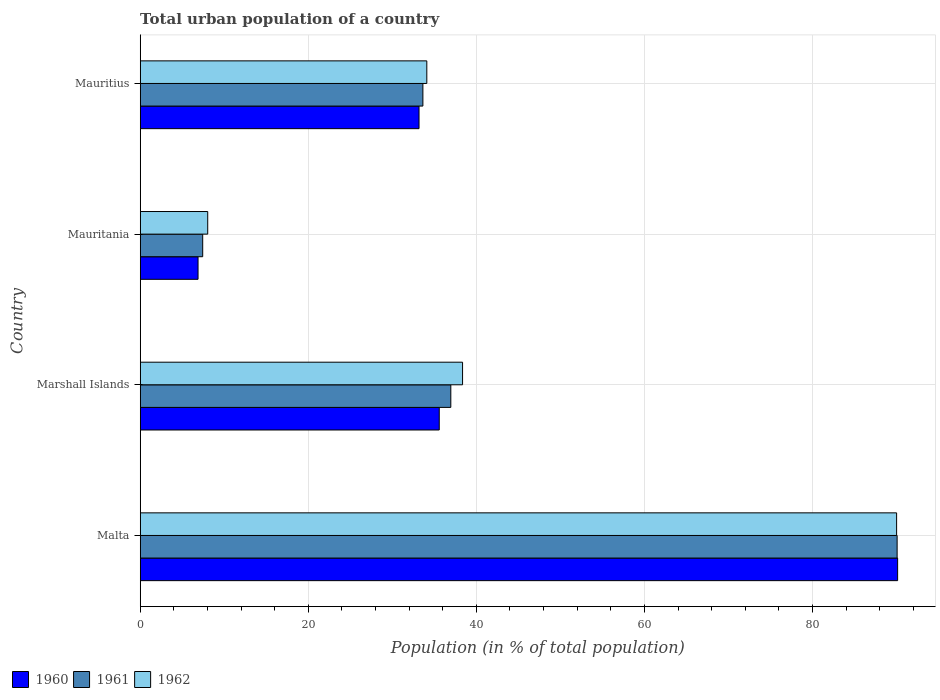How many different coloured bars are there?
Provide a short and direct response. 3. How many groups of bars are there?
Offer a terse response. 4. What is the label of the 1st group of bars from the top?
Provide a short and direct response. Mauritius. What is the urban population in 1961 in Mauritius?
Provide a succinct answer. 33.64. Across all countries, what is the maximum urban population in 1960?
Offer a very short reply. 90.13. Across all countries, what is the minimum urban population in 1960?
Provide a short and direct response. 6.88. In which country was the urban population in 1961 maximum?
Offer a terse response. Malta. In which country was the urban population in 1961 minimum?
Keep it short and to the point. Mauritania. What is the total urban population in 1961 in the graph?
Provide a short and direct response. 168.1. What is the difference between the urban population in 1960 in Marshall Islands and that in Mauritania?
Offer a terse response. 28.7. What is the difference between the urban population in 1962 in Marshall Islands and the urban population in 1960 in Mauritania?
Your response must be concise. 31.48. What is the average urban population in 1960 per country?
Your answer should be very brief. 41.44. What is the difference between the urban population in 1961 and urban population in 1960 in Marshall Islands?
Make the answer very short. 1.38. What is the ratio of the urban population in 1962 in Malta to that in Marshall Islands?
Provide a succinct answer. 2.35. Is the urban population in 1960 in Marshall Islands less than that in Mauritania?
Ensure brevity in your answer.  No. Is the difference between the urban population in 1961 in Marshall Islands and Mauritania greater than the difference between the urban population in 1960 in Marshall Islands and Mauritania?
Offer a very short reply. Yes. What is the difference between the highest and the second highest urban population in 1961?
Your answer should be very brief. 53.11. What is the difference between the highest and the lowest urban population in 1962?
Provide a short and direct response. 81.98. In how many countries, is the urban population in 1960 greater than the average urban population in 1960 taken over all countries?
Keep it short and to the point. 1. What does the 1st bar from the bottom in Malta represents?
Provide a short and direct response. 1960. Are all the bars in the graph horizontal?
Provide a short and direct response. Yes. What is the difference between two consecutive major ticks on the X-axis?
Make the answer very short. 20. Are the values on the major ticks of X-axis written in scientific E-notation?
Offer a terse response. No. Does the graph contain grids?
Your answer should be compact. Yes. Where does the legend appear in the graph?
Your response must be concise. Bottom left. How many legend labels are there?
Keep it short and to the point. 3. How are the legend labels stacked?
Ensure brevity in your answer.  Horizontal. What is the title of the graph?
Your answer should be compact. Total urban population of a country. What is the label or title of the X-axis?
Offer a very short reply. Population (in % of total population). What is the Population (in % of total population) of 1960 in Malta?
Make the answer very short. 90.13. What is the Population (in % of total population) of 1961 in Malta?
Your answer should be compact. 90.07. What is the Population (in % of total population) of 1962 in Malta?
Your answer should be compact. 90.01. What is the Population (in % of total population) in 1960 in Marshall Islands?
Your answer should be compact. 35.58. What is the Population (in % of total population) in 1961 in Marshall Islands?
Ensure brevity in your answer.  36.96. What is the Population (in % of total population) in 1962 in Marshall Islands?
Offer a terse response. 38.36. What is the Population (in % of total population) of 1960 in Mauritania?
Your answer should be very brief. 6.88. What is the Population (in % of total population) in 1961 in Mauritania?
Your answer should be compact. 7.43. What is the Population (in % of total population) of 1962 in Mauritania?
Your answer should be compact. 8.03. What is the Population (in % of total population) of 1960 in Mauritius?
Ensure brevity in your answer.  33.18. What is the Population (in % of total population) in 1961 in Mauritius?
Provide a short and direct response. 33.64. What is the Population (in % of total population) of 1962 in Mauritius?
Provide a succinct answer. 34.1. Across all countries, what is the maximum Population (in % of total population) in 1960?
Provide a succinct answer. 90.13. Across all countries, what is the maximum Population (in % of total population) in 1961?
Your answer should be very brief. 90.07. Across all countries, what is the maximum Population (in % of total population) of 1962?
Offer a very short reply. 90.01. Across all countries, what is the minimum Population (in % of total population) of 1960?
Give a very brief answer. 6.88. Across all countries, what is the minimum Population (in % of total population) of 1961?
Your response must be concise. 7.43. Across all countries, what is the minimum Population (in % of total population) of 1962?
Provide a short and direct response. 8.03. What is the total Population (in % of total population) of 1960 in the graph?
Keep it short and to the point. 165.77. What is the total Population (in % of total population) of 1961 in the graph?
Give a very brief answer. 168.1. What is the total Population (in % of total population) in 1962 in the graph?
Offer a very short reply. 170.5. What is the difference between the Population (in % of total population) in 1960 in Malta and that in Marshall Islands?
Ensure brevity in your answer.  54.55. What is the difference between the Population (in % of total population) of 1961 in Malta and that in Marshall Islands?
Your response must be concise. 53.11. What is the difference between the Population (in % of total population) in 1962 in Malta and that in Marshall Islands?
Give a very brief answer. 51.65. What is the difference between the Population (in % of total population) of 1960 in Malta and that in Mauritania?
Offer a very short reply. 83.25. What is the difference between the Population (in % of total population) in 1961 in Malta and that in Mauritania?
Your answer should be compact. 82.63. What is the difference between the Population (in % of total population) in 1962 in Malta and that in Mauritania?
Make the answer very short. 81.98. What is the difference between the Population (in % of total population) in 1960 in Malta and that in Mauritius?
Ensure brevity in your answer.  56.95. What is the difference between the Population (in % of total population) in 1961 in Malta and that in Mauritius?
Offer a terse response. 56.43. What is the difference between the Population (in % of total population) in 1962 in Malta and that in Mauritius?
Offer a terse response. 55.91. What is the difference between the Population (in % of total population) in 1960 in Marshall Islands and that in Mauritania?
Give a very brief answer. 28.7. What is the difference between the Population (in % of total population) in 1961 in Marshall Islands and that in Mauritania?
Your answer should be compact. 29.52. What is the difference between the Population (in % of total population) of 1962 in Marshall Islands and that in Mauritania?
Your answer should be very brief. 30.33. What is the difference between the Population (in % of total population) of 1960 in Marshall Islands and that in Mauritius?
Make the answer very short. 2.41. What is the difference between the Population (in % of total population) of 1961 in Marshall Islands and that in Mauritius?
Your answer should be compact. 3.32. What is the difference between the Population (in % of total population) in 1962 in Marshall Islands and that in Mauritius?
Give a very brief answer. 4.25. What is the difference between the Population (in % of total population) in 1960 in Mauritania and that in Mauritius?
Ensure brevity in your answer.  -26.3. What is the difference between the Population (in % of total population) in 1961 in Mauritania and that in Mauritius?
Your response must be concise. -26.2. What is the difference between the Population (in % of total population) in 1962 in Mauritania and that in Mauritius?
Offer a terse response. -26.07. What is the difference between the Population (in % of total population) of 1960 in Malta and the Population (in % of total population) of 1961 in Marshall Islands?
Your response must be concise. 53.17. What is the difference between the Population (in % of total population) in 1960 in Malta and the Population (in % of total population) in 1962 in Marshall Islands?
Offer a terse response. 51.77. What is the difference between the Population (in % of total population) of 1961 in Malta and the Population (in % of total population) of 1962 in Marshall Islands?
Give a very brief answer. 51.71. What is the difference between the Population (in % of total population) in 1960 in Malta and the Population (in % of total population) in 1961 in Mauritania?
Make the answer very short. 82.69. What is the difference between the Population (in % of total population) in 1960 in Malta and the Population (in % of total population) in 1962 in Mauritania?
Ensure brevity in your answer.  82.1. What is the difference between the Population (in % of total population) of 1961 in Malta and the Population (in % of total population) of 1962 in Mauritania?
Provide a succinct answer. 82.04. What is the difference between the Population (in % of total population) in 1960 in Malta and the Population (in % of total population) in 1961 in Mauritius?
Provide a succinct answer. 56.49. What is the difference between the Population (in % of total population) of 1960 in Malta and the Population (in % of total population) of 1962 in Mauritius?
Ensure brevity in your answer.  56.03. What is the difference between the Population (in % of total population) in 1961 in Malta and the Population (in % of total population) in 1962 in Mauritius?
Your response must be concise. 55.97. What is the difference between the Population (in % of total population) in 1960 in Marshall Islands and the Population (in % of total population) in 1961 in Mauritania?
Give a very brief answer. 28.15. What is the difference between the Population (in % of total population) of 1960 in Marshall Islands and the Population (in % of total population) of 1962 in Mauritania?
Your answer should be very brief. 27.55. What is the difference between the Population (in % of total population) of 1961 in Marshall Islands and the Population (in % of total population) of 1962 in Mauritania?
Make the answer very short. 28.93. What is the difference between the Population (in % of total population) in 1960 in Marshall Islands and the Population (in % of total population) in 1961 in Mauritius?
Your response must be concise. 1.95. What is the difference between the Population (in % of total population) in 1960 in Marshall Islands and the Population (in % of total population) in 1962 in Mauritius?
Offer a terse response. 1.48. What is the difference between the Population (in % of total population) in 1961 in Marshall Islands and the Population (in % of total population) in 1962 in Mauritius?
Offer a terse response. 2.86. What is the difference between the Population (in % of total population) in 1960 in Mauritania and the Population (in % of total population) in 1961 in Mauritius?
Provide a short and direct response. -26.76. What is the difference between the Population (in % of total population) in 1960 in Mauritania and the Population (in % of total population) in 1962 in Mauritius?
Your response must be concise. -27.22. What is the difference between the Population (in % of total population) in 1961 in Mauritania and the Population (in % of total population) in 1962 in Mauritius?
Provide a succinct answer. -26.67. What is the average Population (in % of total population) of 1960 per country?
Your response must be concise. 41.44. What is the average Population (in % of total population) in 1961 per country?
Your response must be concise. 42.02. What is the average Population (in % of total population) of 1962 per country?
Offer a very short reply. 42.62. What is the difference between the Population (in % of total population) in 1960 and Population (in % of total population) in 1962 in Malta?
Your answer should be very brief. 0.12. What is the difference between the Population (in % of total population) of 1961 and Population (in % of total population) of 1962 in Malta?
Make the answer very short. 0.06. What is the difference between the Population (in % of total population) in 1960 and Population (in % of total population) in 1961 in Marshall Islands?
Your answer should be compact. -1.38. What is the difference between the Population (in % of total population) of 1960 and Population (in % of total population) of 1962 in Marshall Islands?
Make the answer very short. -2.77. What is the difference between the Population (in % of total population) of 1961 and Population (in % of total population) of 1962 in Marshall Islands?
Your answer should be compact. -1.4. What is the difference between the Population (in % of total population) of 1960 and Population (in % of total population) of 1961 in Mauritania?
Your response must be concise. -0.56. What is the difference between the Population (in % of total population) in 1960 and Population (in % of total population) in 1962 in Mauritania?
Give a very brief answer. -1.15. What is the difference between the Population (in % of total population) in 1961 and Population (in % of total population) in 1962 in Mauritania?
Your answer should be very brief. -0.6. What is the difference between the Population (in % of total population) of 1960 and Population (in % of total population) of 1961 in Mauritius?
Make the answer very short. -0.46. What is the difference between the Population (in % of total population) of 1960 and Population (in % of total population) of 1962 in Mauritius?
Offer a very short reply. -0.93. What is the difference between the Population (in % of total population) of 1961 and Population (in % of total population) of 1962 in Mauritius?
Your answer should be compact. -0.47. What is the ratio of the Population (in % of total population) of 1960 in Malta to that in Marshall Islands?
Offer a terse response. 2.53. What is the ratio of the Population (in % of total population) in 1961 in Malta to that in Marshall Islands?
Provide a short and direct response. 2.44. What is the ratio of the Population (in % of total population) of 1962 in Malta to that in Marshall Islands?
Ensure brevity in your answer.  2.35. What is the ratio of the Population (in % of total population) in 1960 in Malta to that in Mauritania?
Your answer should be very brief. 13.1. What is the ratio of the Population (in % of total population) in 1961 in Malta to that in Mauritania?
Offer a very short reply. 12.11. What is the ratio of the Population (in % of total population) in 1962 in Malta to that in Mauritania?
Provide a short and direct response. 11.21. What is the ratio of the Population (in % of total population) of 1960 in Malta to that in Mauritius?
Your response must be concise. 2.72. What is the ratio of the Population (in % of total population) of 1961 in Malta to that in Mauritius?
Keep it short and to the point. 2.68. What is the ratio of the Population (in % of total population) of 1962 in Malta to that in Mauritius?
Offer a very short reply. 2.64. What is the ratio of the Population (in % of total population) in 1960 in Marshall Islands to that in Mauritania?
Make the answer very short. 5.17. What is the ratio of the Population (in % of total population) in 1961 in Marshall Islands to that in Mauritania?
Offer a very short reply. 4.97. What is the ratio of the Population (in % of total population) of 1962 in Marshall Islands to that in Mauritania?
Your response must be concise. 4.78. What is the ratio of the Population (in % of total population) in 1960 in Marshall Islands to that in Mauritius?
Offer a terse response. 1.07. What is the ratio of the Population (in % of total population) in 1961 in Marshall Islands to that in Mauritius?
Your answer should be very brief. 1.1. What is the ratio of the Population (in % of total population) in 1962 in Marshall Islands to that in Mauritius?
Offer a terse response. 1.12. What is the ratio of the Population (in % of total population) in 1960 in Mauritania to that in Mauritius?
Provide a succinct answer. 0.21. What is the ratio of the Population (in % of total population) of 1961 in Mauritania to that in Mauritius?
Make the answer very short. 0.22. What is the ratio of the Population (in % of total population) in 1962 in Mauritania to that in Mauritius?
Your response must be concise. 0.24. What is the difference between the highest and the second highest Population (in % of total population) of 1960?
Your response must be concise. 54.55. What is the difference between the highest and the second highest Population (in % of total population) in 1961?
Provide a succinct answer. 53.11. What is the difference between the highest and the second highest Population (in % of total population) of 1962?
Provide a succinct answer. 51.65. What is the difference between the highest and the lowest Population (in % of total population) of 1960?
Ensure brevity in your answer.  83.25. What is the difference between the highest and the lowest Population (in % of total population) in 1961?
Your response must be concise. 82.63. What is the difference between the highest and the lowest Population (in % of total population) of 1962?
Provide a succinct answer. 81.98. 